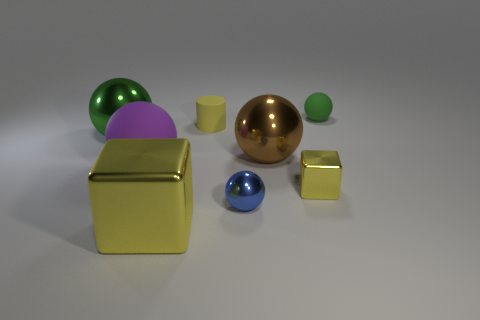What number of other things are the same size as the blue ball?
Give a very brief answer. 3. There is a blue metal thing; how many small metal things are behind it?
Ensure brevity in your answer.  1. Are there the same number of tiny green matte things that are on the left side of the purple matte sphere and tiny balls behind the brown metal sphere?
Ensure brevity in your answer.  No. What size is the brown thing that is the same shape as the large purple rubber thing?
Provide a short and direct response. Large. There is a green thing on the right side of the brown ball; what is its shape?
Offer a very short reply. Sphere. Is the sphere to the left of the purple matte thing made of the same material as the big ball on the right side of the big purple object?
Offer a terse response. Yes. What is the shape of the tiny yellow shiny thing?
Keep it short and to the point. Cube. Are there the same number of big yellow things that are right of the big cube and tiny gray cylinders?
Give a very brief answer. Yes. The thing that is the same color as the small rubber sphere is what size?
Provide a succinct answer. Large. Are there any green things made of the same material as the small blue ball?
Offer a terse response. Yes. 